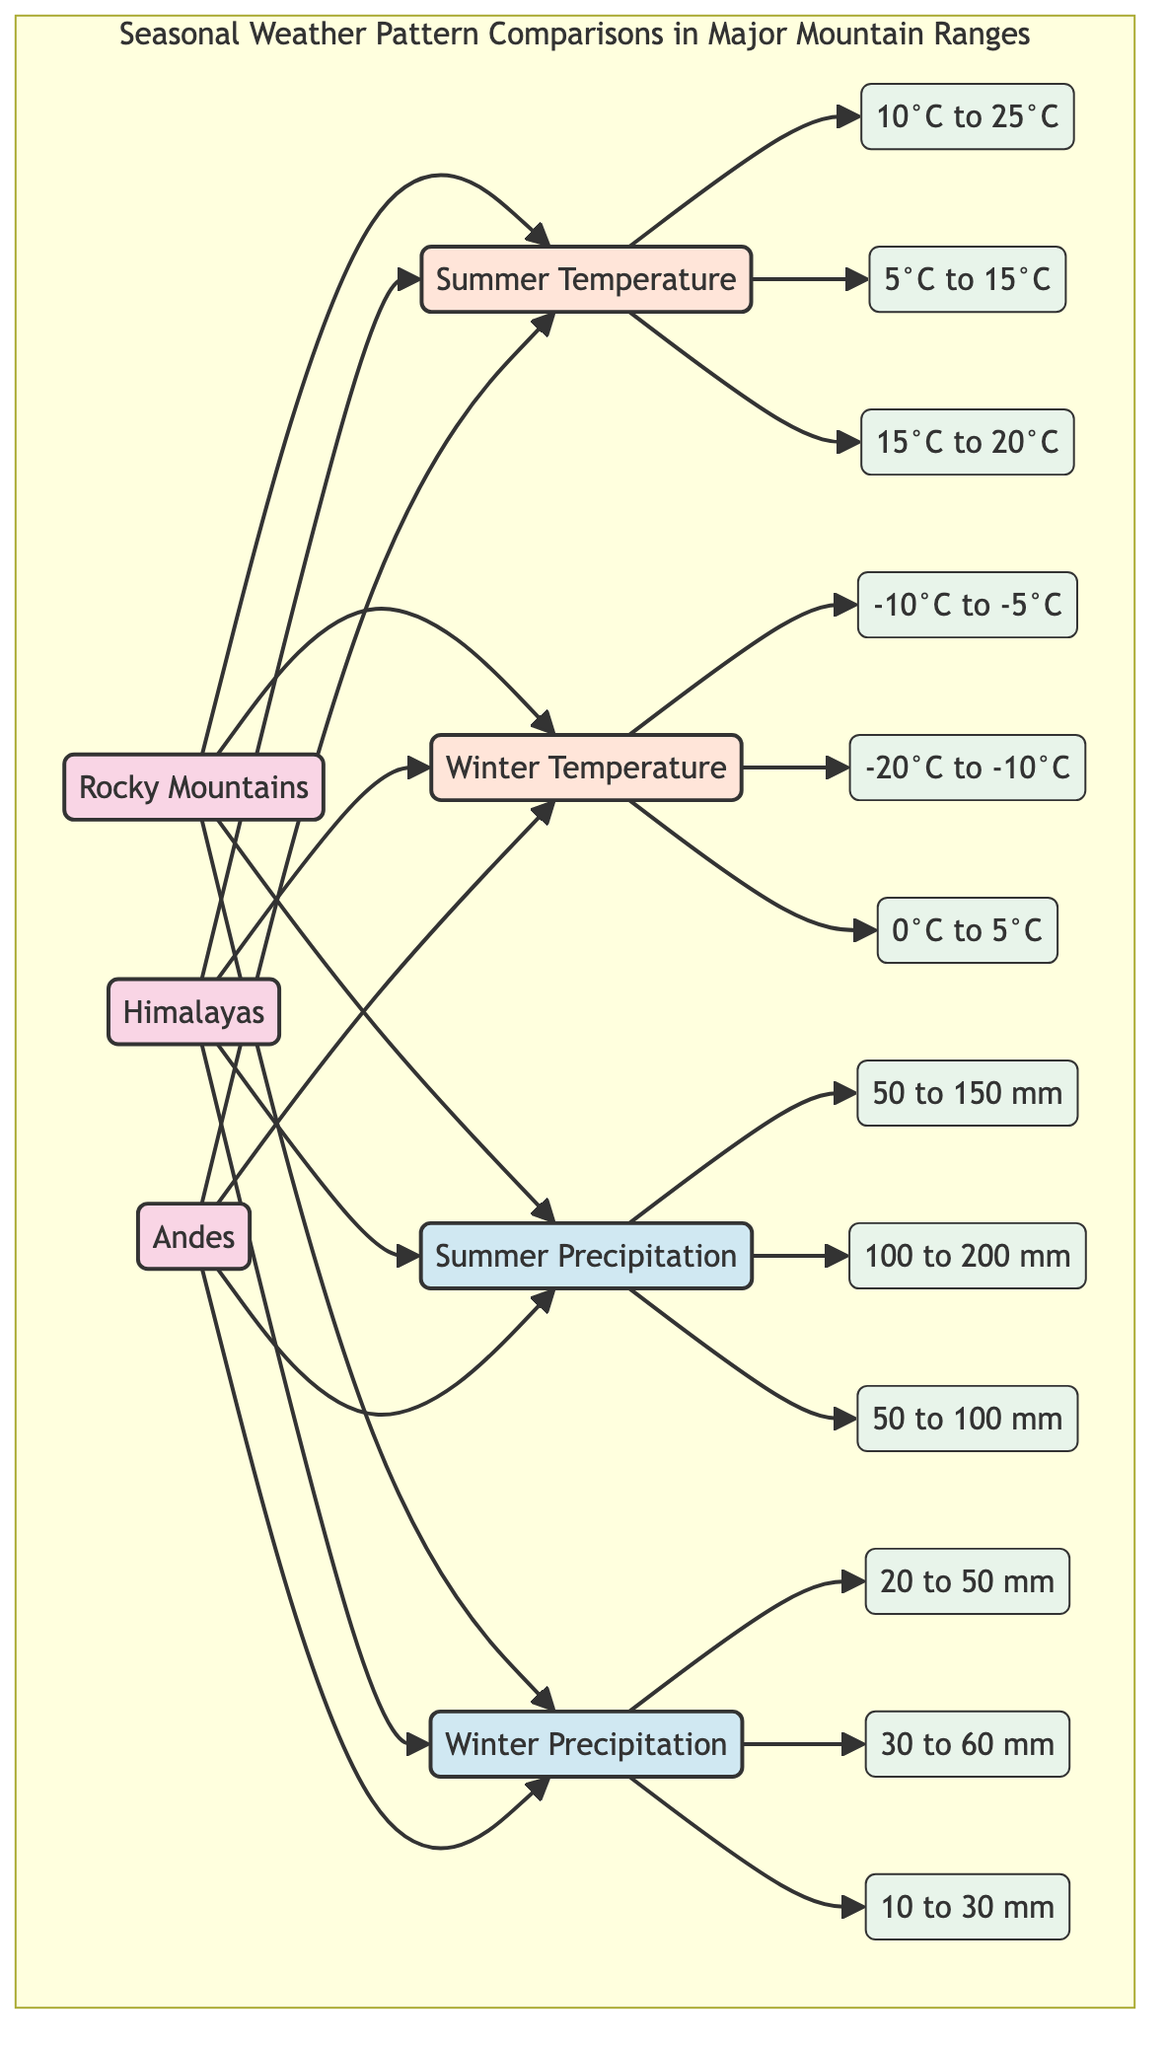What is the average summer temperature in the Andes? The diagram states that the average summer temperature in the Andes is between 15°C to 20°C.
Answer: 15°C to 20°C What is the average winter precipitation for the Rocky Mountains? According to the diagram, the average winter precipitation for the Rocky Mountains is between 20 to 50 mm.
Answer: 20 to 50 mm Which mountain range has the highest average winter temperature? By reviewing the average winter temperatures, the Andes have an average winter temperature of 0°C to 5°C, which is higher than the other ranges (Rocky Mountains: -10°C to -5°C and Himalayas: -20°C to -10°C).
Answer: Andes How many mountain ranges are compared in this diagram? The diagram features three mountain ranges—Rocky Mountains, Himalayas, and Andes. Thus, the total is three.
Answer: 3 What is the range of summer precipitation in the Himalayas? The diagram indicates that the average summer precipitation in the Himalayas is between 100 to 200 mm.
Answer: 100 to 200 mm Which mountain range experiences the lowest average summer temperature? The average summer temperature of the Himalayan range (5°C to 15°C) is lower than that of the Rocky Mountains (10°C to 25°C) and the Andes (15°C to 20°C).
Answer: Himalayas What is the comparative relationship between summer and winter temperatures in the Rocky Mountains? For the Rocky Mountains, the average summer temperature is 10°C to 25°C, while the average winter temperature drops to -10°C to -5°C, showing a significant decline in temperature from summer to winter.
Answer: Significant decline What is the highest average summer precipitation among the three mountain ranges? The average summer precipitation is highest in the Himalayas at 100 to 200 mm, compared to the Rocky Mountains (50 to 150 mm) and the Andes (50 to 100 mm).
Answer: Himalayas What is the average winter precipitation range in the Andes? According to the diagram, the average winter precipitation in the Andes is between 10 to 30 mm.
Answer: 10 to 30 mm 